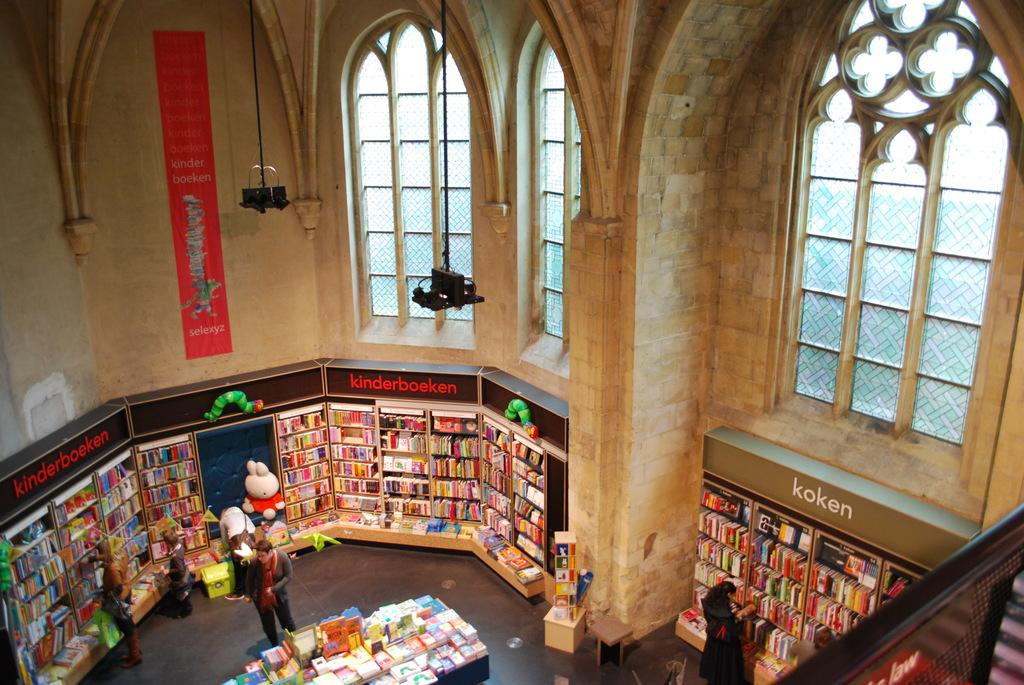Provide a one-sentence caption for the provided image. A foreign language book store has a section devoted to kinderboeken. 